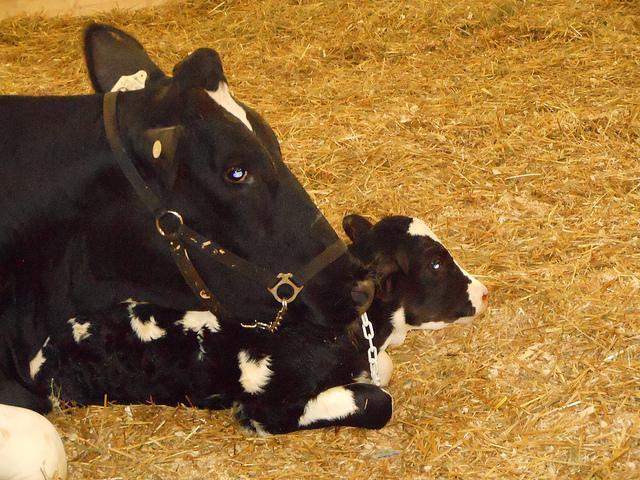How many cows are there?
Give a very brief answer. 2. How many cows are in the photo?
Give a very brief answer. 2. 